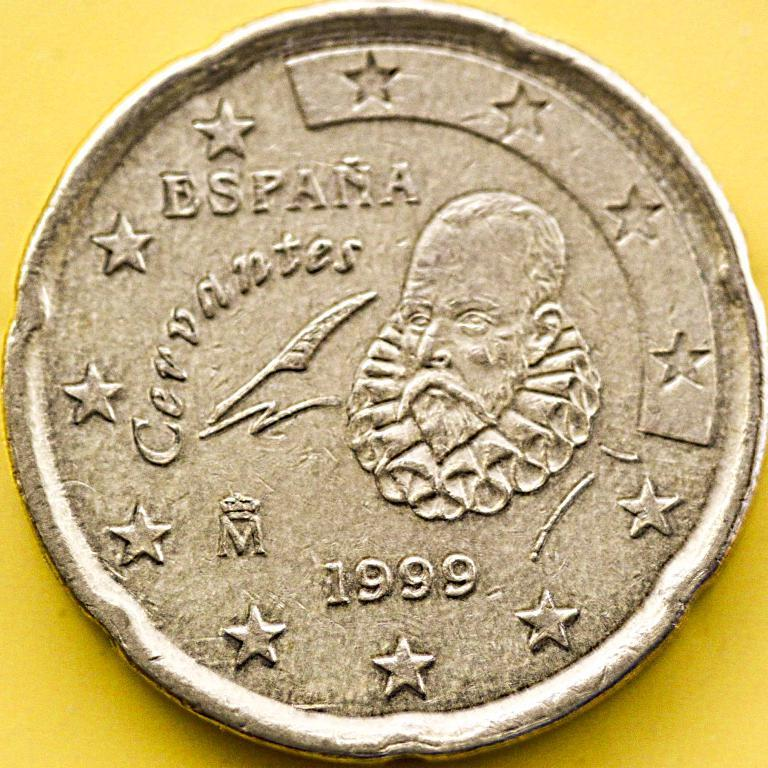<image>
Relay a brief, clear account of the picture shown. A rare coin from Spain it reads Espana Corvantes. 